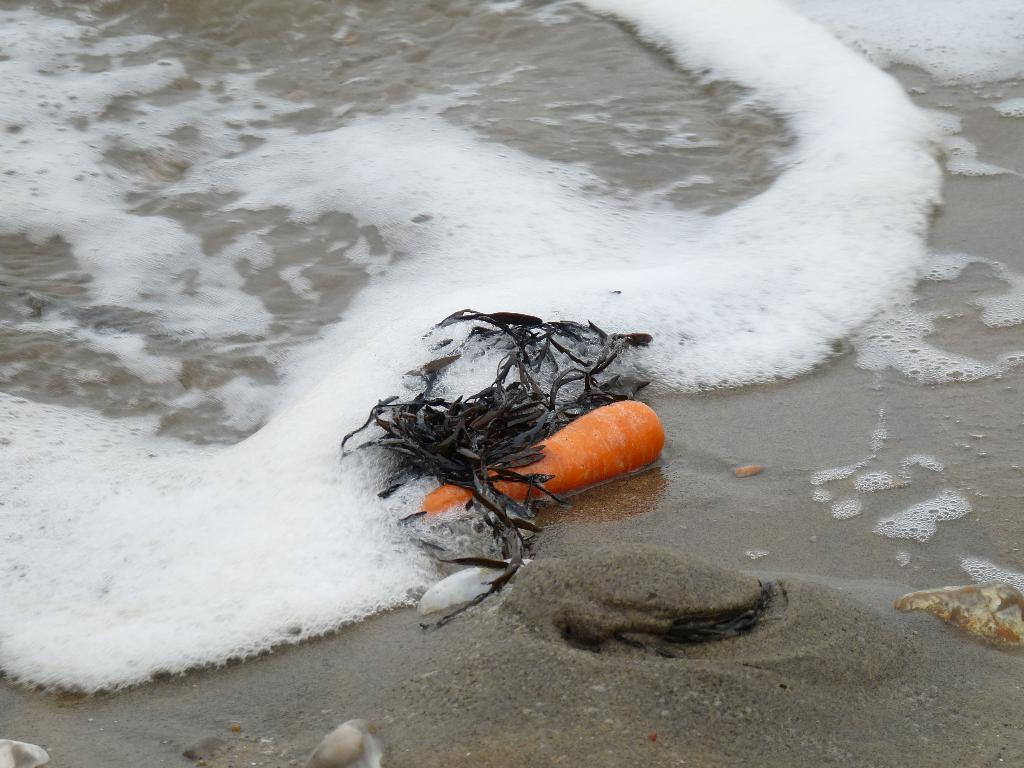What vegetable is present in the image? There is a carrot in the image. What other object can be seen in the image? There is a shell in the image. What type of plant material is visible in the image? There are dried leaves in the image. On what surface are the objects placed? The objects are on sand in the image. What can be seen in the background of the image? There is foam and water visible in the image. What type of blade is being used to cut the potato in the image? There is no potato or blade present in the image. 